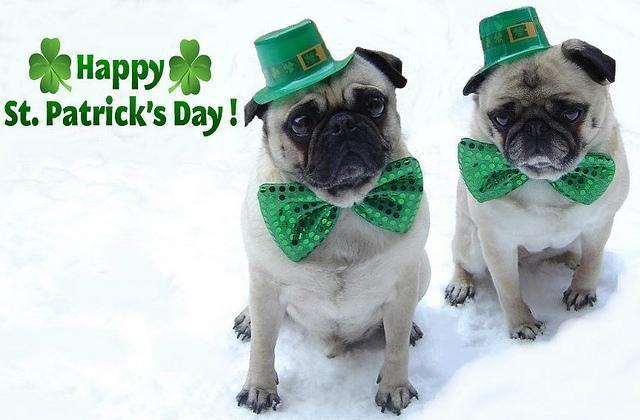How many dogs can be seen?
Give a very brief answer. 2. How many ties are visible?
Give a very brief answer. 2. How many cats have their eyes closed?
Give a very brief answer. 0. 